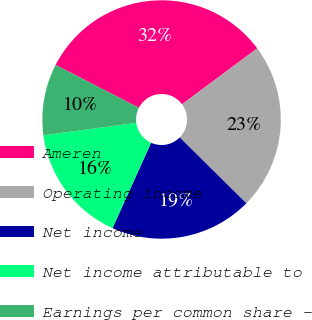Convert chart. <chart><loc_0><loc_0><loc_500><loc_500><pie_chart><fcel>Ameren<fcel>Operating income<fcel>Net income<fcel>Net income attributable to<fcel>Earnings per common share -<nl><fcel>32.26%<fcel>22.58%<fcel>19.35%<fcel>16.13%<fcel>9.68%<nl></chart> 